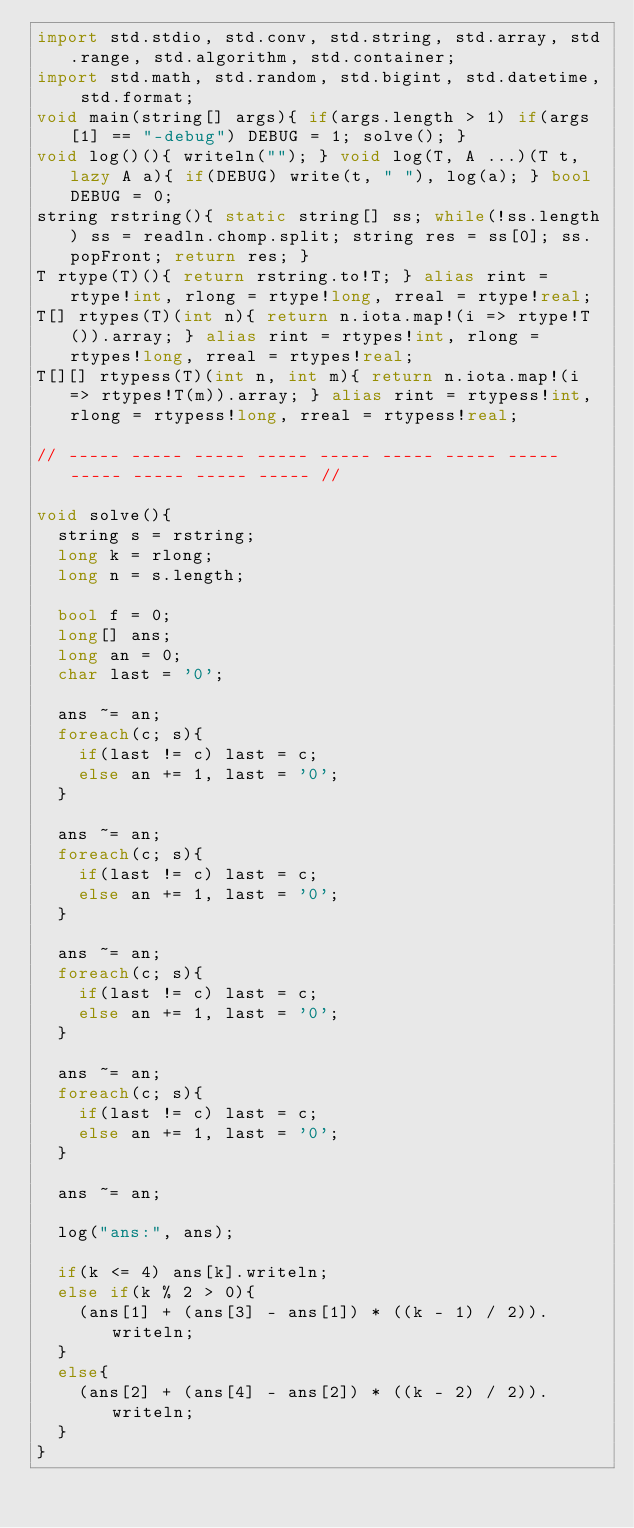Convert code to text. <code><loc_0><loc_0><loc_500><loc_500><_D_>import std.stdio, std.conv, std.string, std.array, std.range, std.algorithm, std.container;
import std.math, std.random, std.bigint, std.datetime, std.format;
void main(string[] args){ if(args.length > 1) if(args[1] == "-debug") DEBUG = 1; solve(); }
void log()(){ writeln(""); } void log(T, A ...)(T t, lazy A a){ if(DEBUG) write(t, " "), log(a); } bool DEBUG = 0; 
string rstring(){ static string[] ss; while(!ss.length) ss = readln.chomp.split; string res = ss[0]; ss.popFront; return res; }
T rtype(T)(){ return rstring.to!T; } alias rint = rtype!int, rlong = rtype!long, rreal = rtype!real;
T[] rtypes(T)(int n){ return n.iota.map!(i => rtype!T()).array; } alias rint = rtypes!int, rlong = rtypes!long, rreal = rtypes!real;
T[][] rtypess(T)(int n, int m){ return n.iota.map!(i => rtypes!T(m)).array; } alias rint = rtypess!int, rlong = rtypess!long, rreal = rtypess!real;

// ----- ----- ----- ----- ----- ----- ----- ----- ----- ----- ----- ----- //

void solve(){
	string s = rstring;
	long k = rlong;
	long n = s.length;
	
	bool f = 0;
	long[] ans;
	long an = 0;
	char last = '0';
	
	ans ~= an;
	foreach(c; s){
		if(last != c) last = c;
		else an += 1, last = '0';
	}
	
	ans ~= an;
	foreach(c; s){
		if(last != c) last = c;
		else an += 1, last = '0';
	}
	
	ans ~= an;
	foreach(c; s){
		if(last != c) last = c;
		else an += 1, last = '0';
	}
	
	ans ~= an;
	foreach(c; s){
		if(last != c) last = c;
		else an += 1, last = '0';
	}
	
	ans ~= an;
	
	log("ans:", ans);
	
	if(k <= 4) ans[k].writeln;
	else if(k % 2 > 0){
		(ans[1] + (ans[3] - ans[1]) * ((k - 1) / 2)).writeln;
	}
	else{
		(ans[2] + (ans[4] - ans[2]) * ((k - 2) / 2)).writeln;
	}
}
</code> 